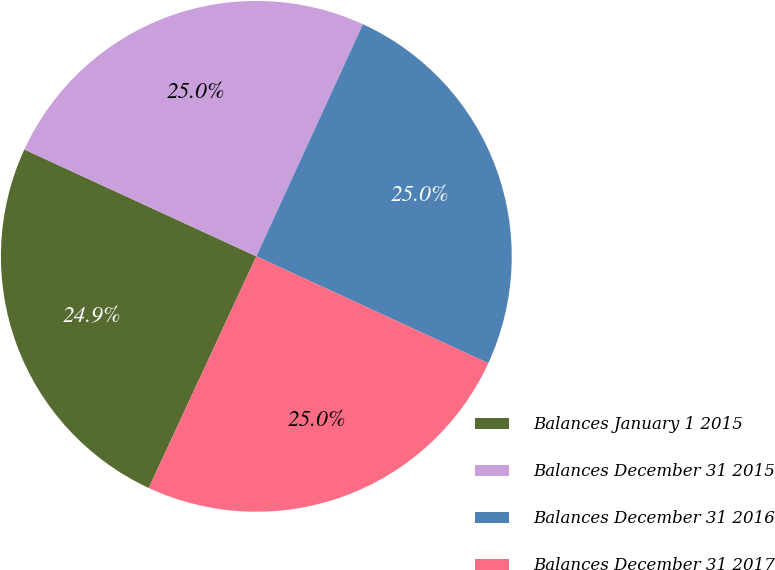Convert chart. <chart><loc_0><loc_0><loc_500><loc_500><pie_chart><fcel>Balances January 1 2015<fcel>Balances December 31 2015<fcel>Balances December 31 2016<fcel>Balances December 31 2017<nl><fcel>24.95%<fcel>24.99%<fcel>25.02%<fcel>25.05%<nl></chart> 